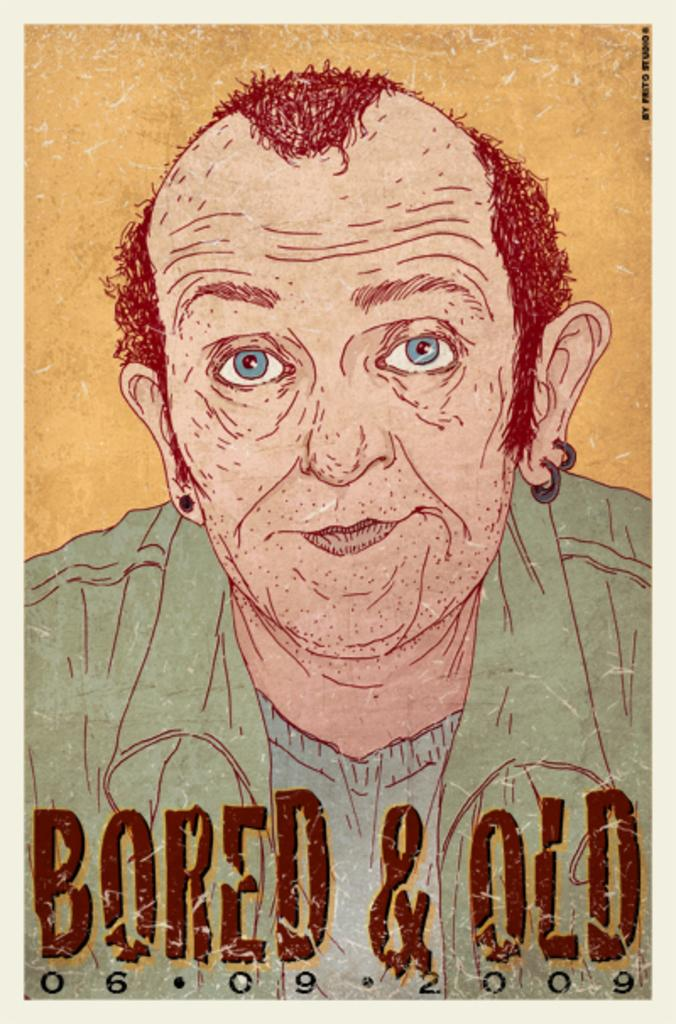<image>
Render a clear and concise summary of the photo. A poster of a balding red haired cartoon man says "Bored & Old" at the bottom in big letters. 